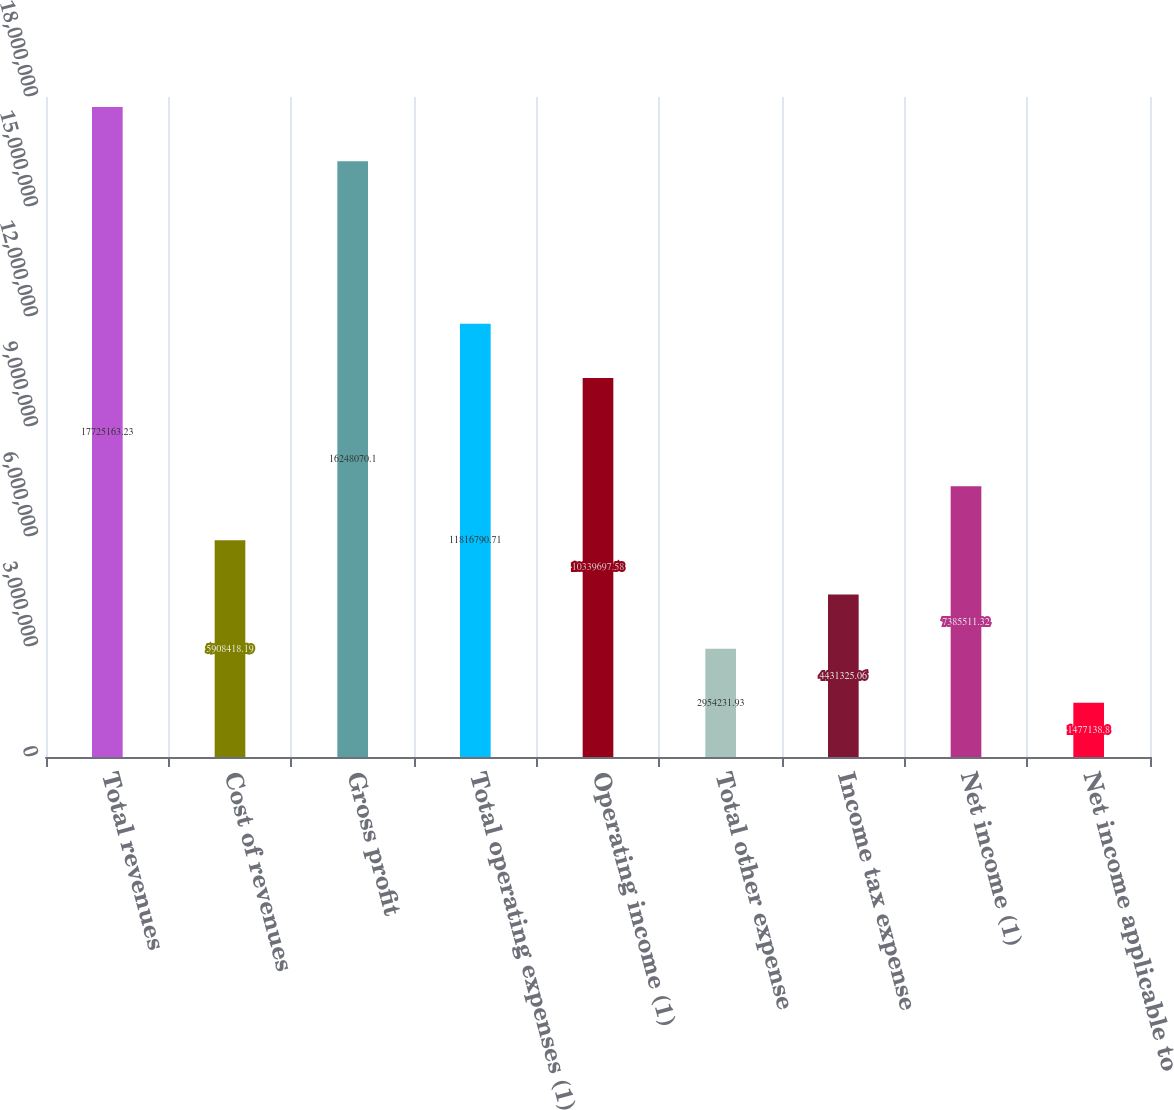Convert chart. <chart><loc_0><loc_0><loc_500><loc_500><bar_chart><fcel>Total revenues<fcel>Cost of revenues<fcel>Gross profit<fcel>Total operating expenses (1)<fcel>Operating income (1)<fcel>Total other expense<fcel>Income tax expense<fcel>Net income (1)<fcel>Net income applicable to<nl><fcel>1.77252e+07<fcel>5.90842e+06<fcel>1.62481e+07<fcel>1.18168e+07<fcel>1.03397e+07<fcel>2.95423e+06<fcel>4.43133e+06<fcel>7.38551e+06<fcel>1.47714e+06<nl></chart> 